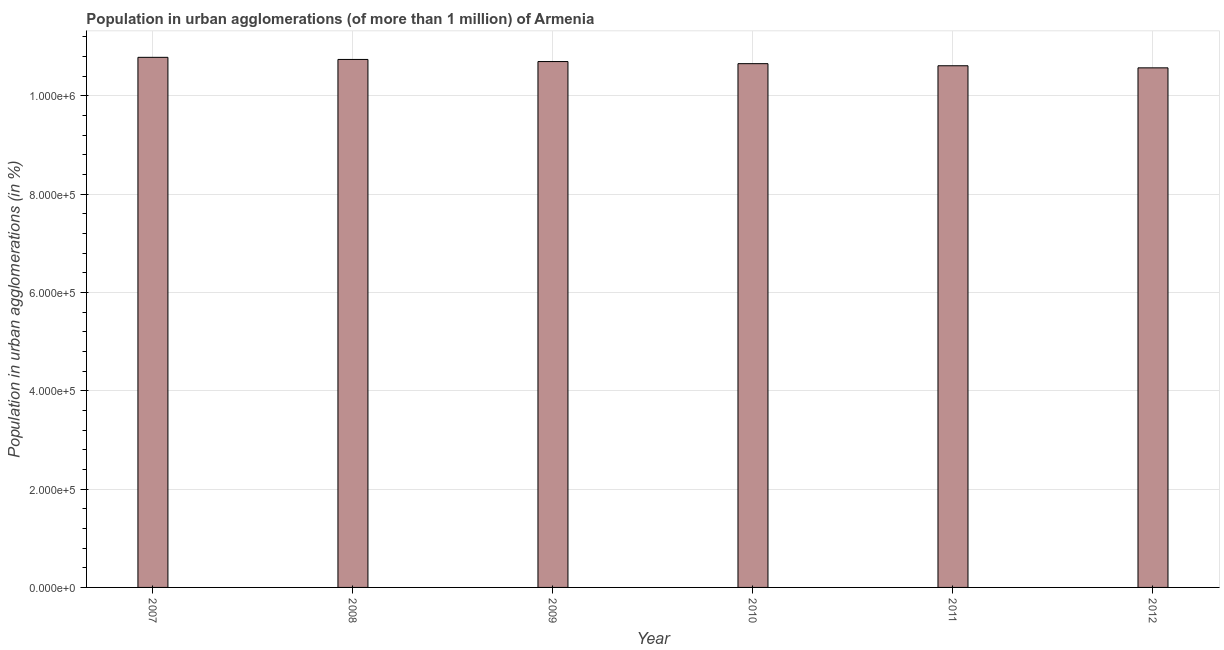Does the graph contain any zero values?
Provide a short and direct response. No. What is the title of the graph?
Keep it short and to the point. Population in urban agglomerations (of more than 1 million) of Armenia. What is the label or title of the Y-axis?
Ensure brevity in your answer.  Population in urban agglomerations (in %). What is the population in urban agglomerations in 2009?
Provide a short and direct response. 1.07e+06. Across all years, what is the maximum population in urban agglomerations?
Your answer should be very brief. 1.08e+06. Across all years, what is the minimum population in urban agglomerations?
Your answer should be compact. 1.06e+06. In which year was the population in urban agglomerations minimum?
Your response must be concise. 2012. What is the sum of the population in urban agglomerations?
Offer a terse response. 6.41e+06. What is the difference between the population in urban agglomerations in 2008 and 2011?
Ensure brevity in your answer.  1.28e+04. What is the average population in urban agglomerations per year?
Provide a succinct answer. 1.07e+06. What is the median population in urban agglomerations?
Your answer should be compact. 1.07e+06. Is the population in urban agglomerations in 2009 less than that in 2011?
Ensure brevity in your answer.  No. Is the difference between the population in urban agglomerations in 2009 and 2010 greater than the difference between any two years?
Offer a very short reply. No. What is the difference between the highest and the second highest population in urban agglomerations?
Your response must be concise. 4317. Is the sum of the population in urban agglomerations in 2008 and 2010 greater than the maximum population in urban agglomerations across all years?
Your response must be concise. Yes. What is the difference between the highest and the lowest population in urban agglomerations?
Ensure brevity in your answer.  2.14e+04. In how many years, is the population in urban agglomerations greater than the average population in urban agglomerations taken over all years?
Provide a succinct answer. 3. What is the Population in urban agglomerations (in %) of 2007?
Give a very brief answer. 1.08e+06. What is the Population in urban agglomerations (in %) of 2008?
Provide a short and direct response. 1.07e+06. What is the Population in urban agglomerations (in %) of 2009?
Provide a succinct answer. 1.07e+06. What is the Population in urban agglomerations (in %) in 2010?
Offer a terse response. 1.07e+06. What is the Population in urban agglomerations (in %) in 2011?
Offer a very short reply. 1.06e+06. What is the Population in urban agglomerations (in %) of 2012?
Keep it short and to the point. 1.06e+06. What is the difference between the Population in urban agglomerations (in %) in 2007 and 2008?
Offer a very short reply. 4317. What is the difference between the Population in urban agglomerations (in %) in 2007 and 2009?
Provide a succinct answer. 8606. What is the difference between the Population in urban agglomerations (in %) in 2007 and 2010?
Make the answer very short. 1.29e+04. What is the difference between the Population in urban agglomerations (in %) in 2007 and 2011?
Your answer should be compact. 1.71e+04. What is the difference between the Population in urban agglomerations (in %) in 2007 and 2012?
Your answer should be compact. 2.14e+04. What is the difference between the Population in urban agglomerations (in %) in 2008 and 2009?
Your answer should be very brief. 4289. What is the difference between the Population in urban agglomerations (in %) in 2008 and 2010?
Provide a short and direct response. 8565. What is the difference between the Population in urban agglomerations (in %) in 2008 and 2011?
Your answer should be very brief. 1.28e+04. What is the difference between the Population in urban agglomerations (in %) in 2008 and 2012?
Your answer should be compact. 1.71e+04. What is the difference between the Population in urban agglomerations (in %) in 2009 and 2010?
Provide a short and direct response. 4276. What is the difference between the Population in urban agglomerations (in %) in 2009 and 2011?
Offer a very short reply. 8536. What is the difference between the Population in urban agglomerations (in %) in 2009 and 2012?
Keep it short and to the point. 1.28e+04. What is the difference between the Population in urban agglomerations (in %) in 2010 and 2011?
Your response must be concise. 4260. What is the difference between the Population in urban agglomerations (in %) in 2010 and 2012?
Your answer should be very brief. 8509. What is the difference between the Population in urban agglomerations (in %) in 2011 and 2012?
Ensure brevity in your answer.  4249. What is the ratio of the Population in urban agglomerations (in %) in 2007 to that in 2008?
Your answer should be compact. 1. What is the ratio of the Population in urban agglomerations (in %) in 2007 to that in 2009?
Make the answer very short. 1.01. What is the ratio of the Population in urban agglomerations (in %) in 2007 to that in 2010?
Keep it short and to the point. 1.01. What is the ratio of the Population in urban agglomerations (in %) in 2007 to that in 2011?
Offer a terse response. 1.02. What is the ratio of the Population in urban agglomerations (in %) in 2008 to that in 2010?
Make the answer very short. 1.01. What is the ratio of the Population in urban agglomerations (in %) in 2008 to that in 2012?
Your response must be concise. 1.02. What is the ratio of the Population in urban agglomerations (in %) in 2009 to that in 2010?
Keep it short and to the point. 1. What is the ratio of the Population in urban agglomerations (in %) in 2010 to that in 2012?
Give a very brief answer. 1.01. 